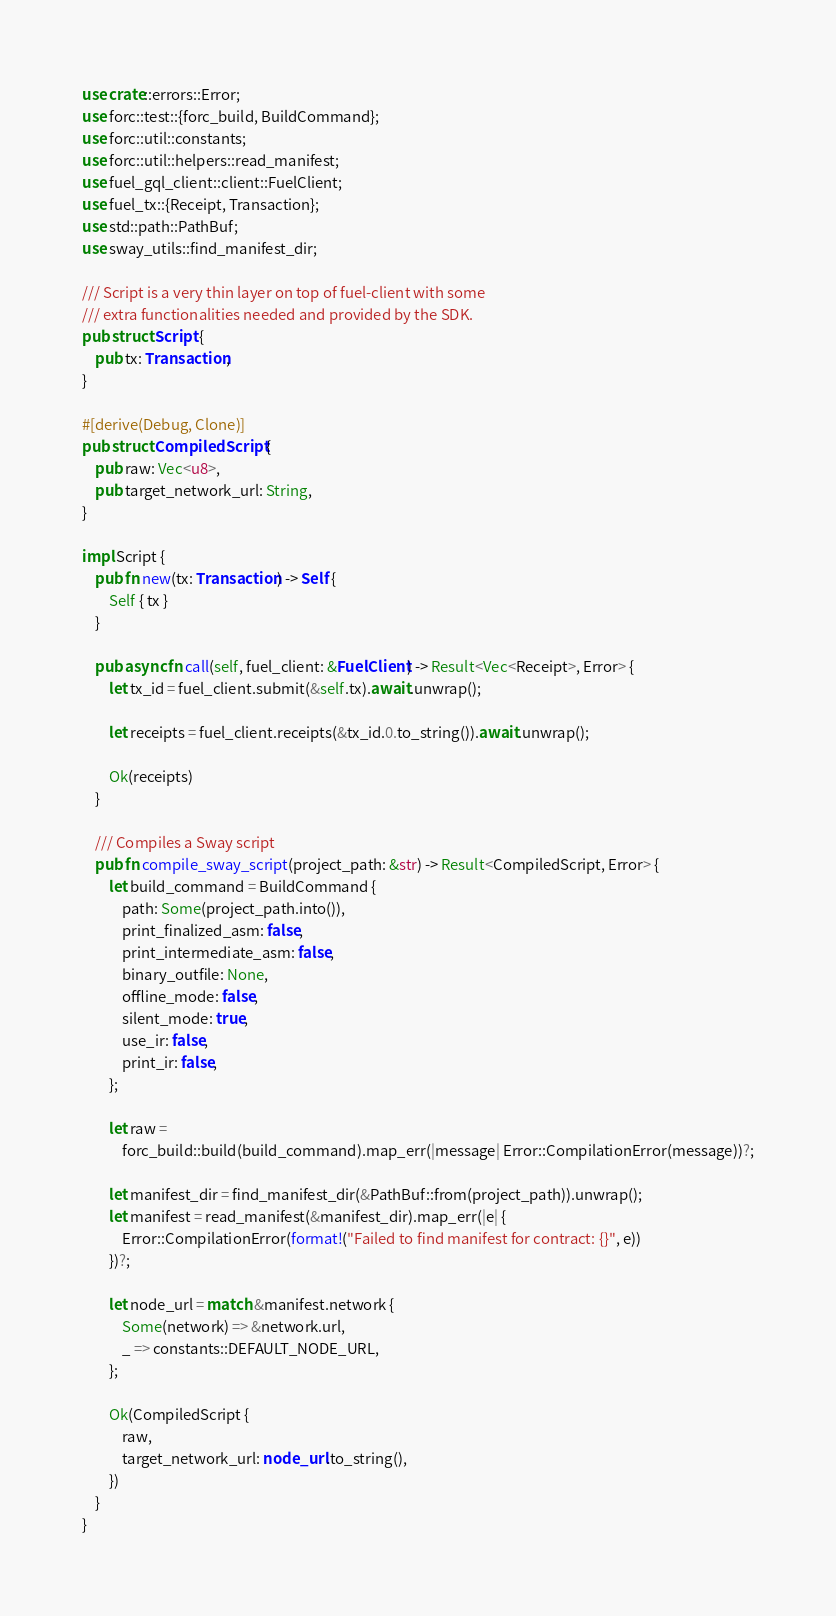<code> <loc_0><loc_0><loc_500><loc_500><_Rust_>use crate::errors::Error;
use forc::test::{forc_build, BuildCommand};
use forc::util::constants;
use forc::util::helpers::read_manifest;
use fuel_gql_client::client::FuelClient;
use fuel_tx::{Receipt, Transaction};
use std::path::PathBuf;
use sway_utils::find_manifest_dir;

/// Script is a very thin layer on top of fuel-client with some
/// extra functionalities needed and provided by the SDK.
pub struct Script {
    pub tx: Transaction,
}

#[derive(Debug, Clone)]
pub struct CompiledScript {
    pub raw: Vec<u8>,
    pub target_network_url: String,
}

impl Script {
    pub fn new(tx: Transaction) -> Self {
        Self { tx }
    }

    pub async fn call(self, fuel_client: &FuelClient) -> Result<Vec<Receipt>, Error> {
        let tx_id = fuel_client.submit(&self.tx).await.unwrap();

        let receipts = fuel_client.receipts(&tx_id.0.to_string()).await.unwrap();

        Ok(receipts)
    }

    /// Compiles a Sway script
    pub fn compile_sway_script(project_path: &str) -> Result<CompiledScript, Error> {
        let build_command = BuildCommand {
            path: Some(project_path.into()),
            print_finalized_asm: false,
            print_intermediate_asm: false,
            binary_outfile: None,
            offline_mode: false,
            silent_mode: true,
            use_ir: false,
            print_ir: false,
        };

        let raw =
            forc_build::build(build_command).map_err(|message| Error::CompilationError(message))?;

        let manifest_dir = find_manifest_dir(&PathBuf::from(project_path)).unwrap();
        let manifest = read_manifest(&manifest_dir).map_err(|e| {
            Error::CompilationError(format!("Failed to find manifest for contract: {}", e))
        })?;

        let node_url = match &manifest.network {
            Some(network) => &network.url,
            _ => constants::DEFAULT_NODE_URL,
        };

        Ok(CompiledScript {
            raw,
            target_network_url: node_url.to_string(),
        })
    }
}
</code> 